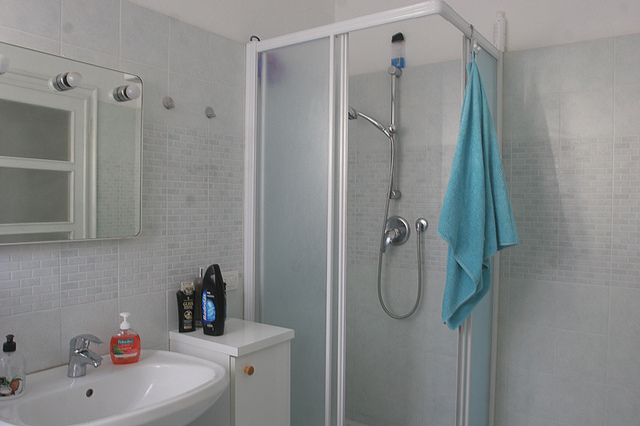Is there any indication of the room's ventilation system? An air vent is not directly visible in the image, suggesting the room's ventilation might be integrated into the ceiling or walls outside of the frame. 